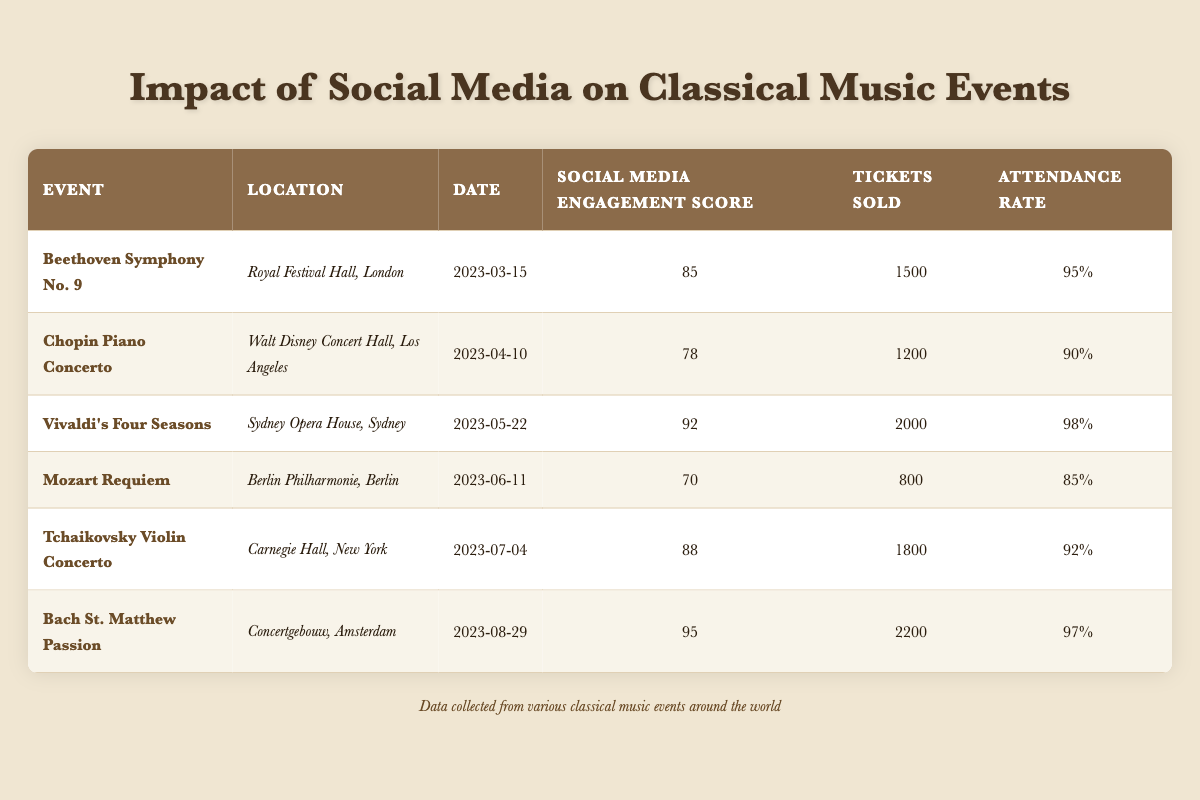What is the Social Media Engagement Score for the event "Vivaldi's Four Seasons"? The Social Media Engagement Score for "Vivaldi's Four Seasons," which is listed in the table, is directly stated as 92.
Answer: 92 What event had the highest attendance rate? By reviewing the Attendance Rate column, "Vivaldi's Four Seasons" has the highest attendance rate at 98%.
Answer: 98% How many tickets were sold for the "Mozart Requiem"? The number of tickets sold for "Mozart Requiem" is stated in the Tickets Sold column as 800.
Answer: 800 What is the average Social Media Engagement Score for all events listed? The scores are 85, 78, 92, 70, 88, and 95. Summing these gives 85 + 78 + 92 + 70 + 88 + 95 = 508, and dividing by 6 (the number of events) gives an average of 84.67.
Answer: 84.67 Is it true that the "Chopin Piano Concerto" had more tickets sold than the "Mozart Requiem"? "Chopin Piano Concerto" sold 1200 tickets, while "Mozart Requiem" sold 800 tickets. Since 1200 is greater than 800, the statement is true.
Answer: Yes Which event in the table had the lowest Social Media Engagement Score, and what was it? Scanning the Social Media Engagement Score column, "Mozart Requiem" has the lowest score at 70.
Answer: 70 What was the total number of tickets sold across all events? The total tickets sold are 1500 + 1200 + 2000 + 800 + 1800 + 2200 = 10500. Thus, the total tickets sold across all events is 10500.
Answer: 10500 Was the attendance rate for "Bach St. Matthew Passion" greater than 95%? The attendance rate for "Bach St. Matthew Passion" is listed as 97%, which is greater than 95%. Therefore, the statement is true.
Answer: Yes How does the attendance rate of "Tchaikovsky Violin Concerto" compare to "Chopin Piano Concerto"? The attendance rate for "Tchaikovsky Violin Concerto" is 92%, while for "Chopin Piano Concerto," it is 90%. Since 92% is greater than 90%, the attendance rate for Tchaikovsky is higher.
Answer: Tchaikovsky Violin Concerto is higher 